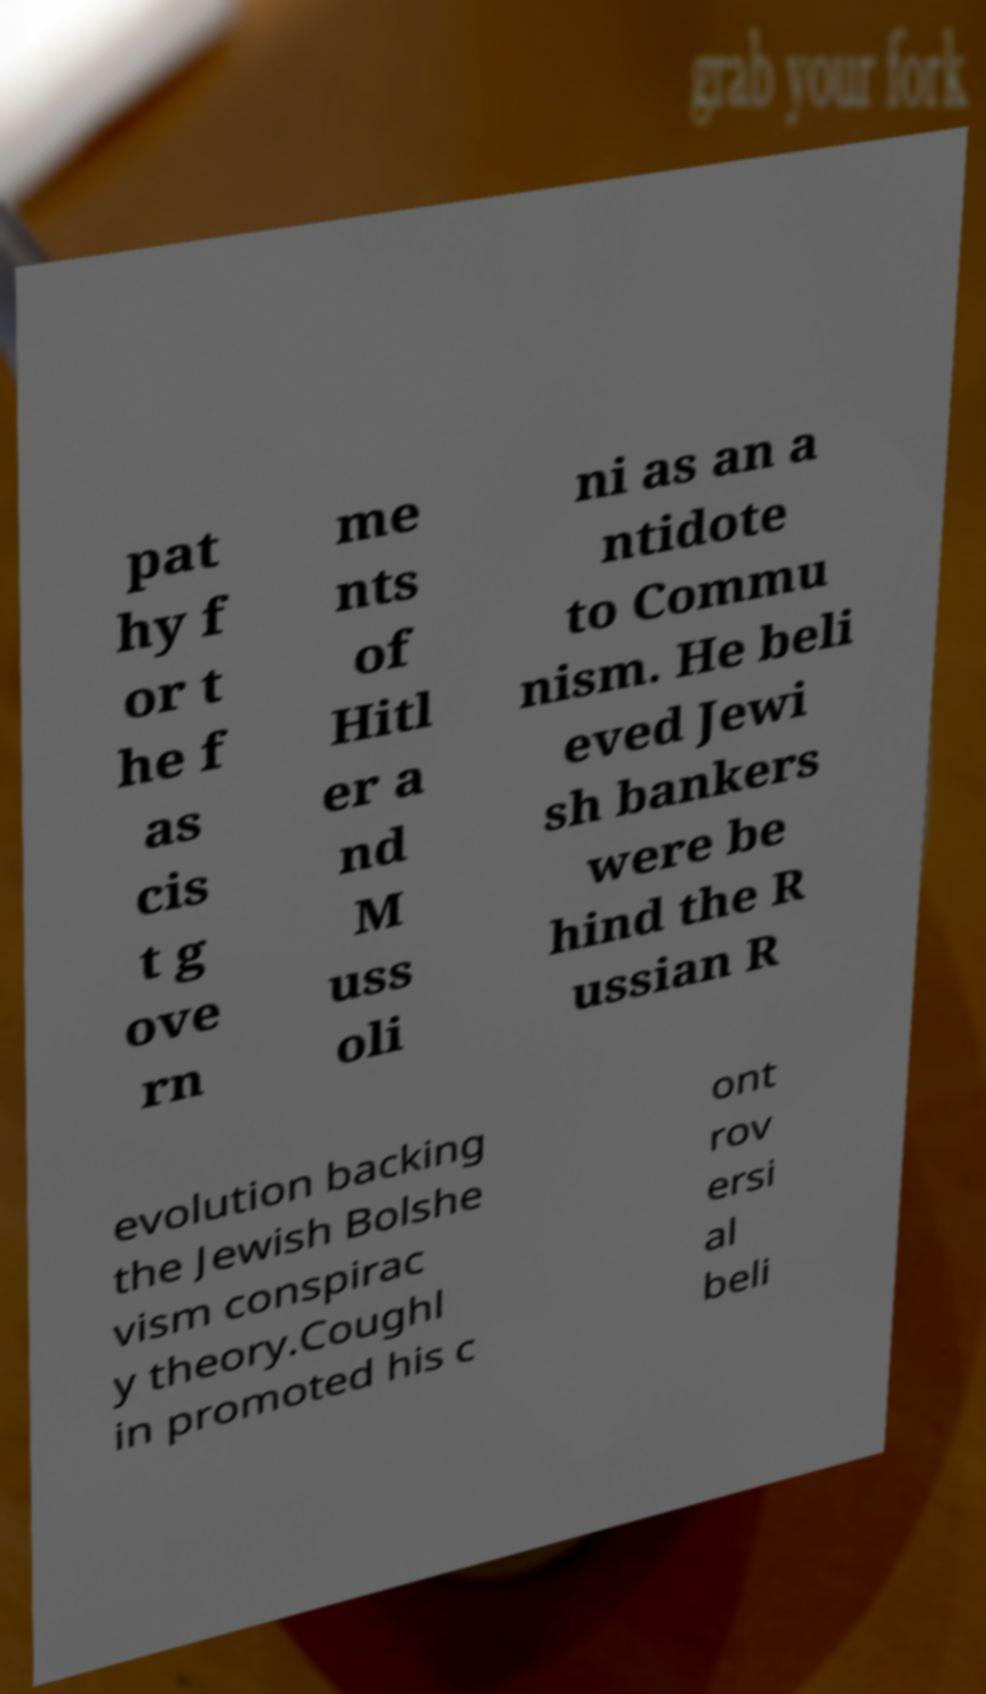Can you accurately transcribe the text from the provided image for me? pat hy f or t he f as cis t g ove rn me nts of Hitl er a nd M uss oli ni as an a ntidote to Commu nism. He beli eved Jewi sh bankers were be hind the R ussian R evolution backing the Jewish Bolshe vism conspirac y theory.Coughl in promoted his c ont rov ersi al beli 